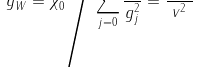Convert formula to latex. <formula><loc_0><loc_0><loc_500><loc_500>g _ { W } ^ { 2 } = \chi _ { 0 } ^ { 2 } \Big / \sum _ { j = 0 } ^ { N } \frac { \chi _ { j } ^ { 2 } } { g _ { j } ^ { 2 } } = \frac { M _ { W } ^ { 2 } } { v ^ { 2 } }</formula> 